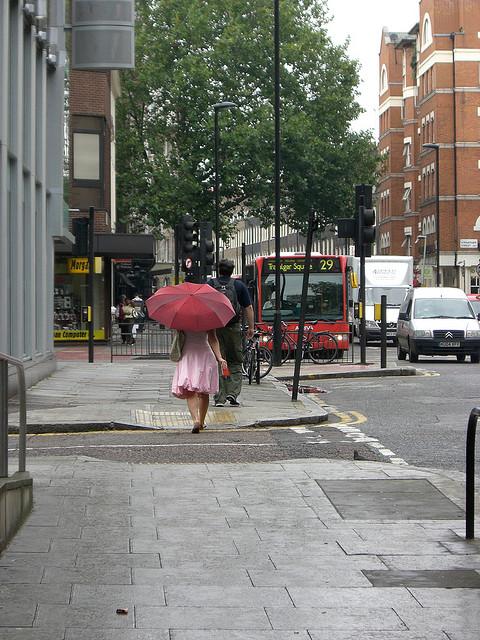What number is on the red bus?
Write a very short answer. 29. How many umbrellas are open?
Write a very short answer. 1. Are they walking on a sidewalk?
Quick response, please. Yes. What color is the woman's umbrella?
Short answer required. Red. Are there any trees?
Be succinct. Yes. What color is the child's raincoat?
Quick response, please. Pink. 